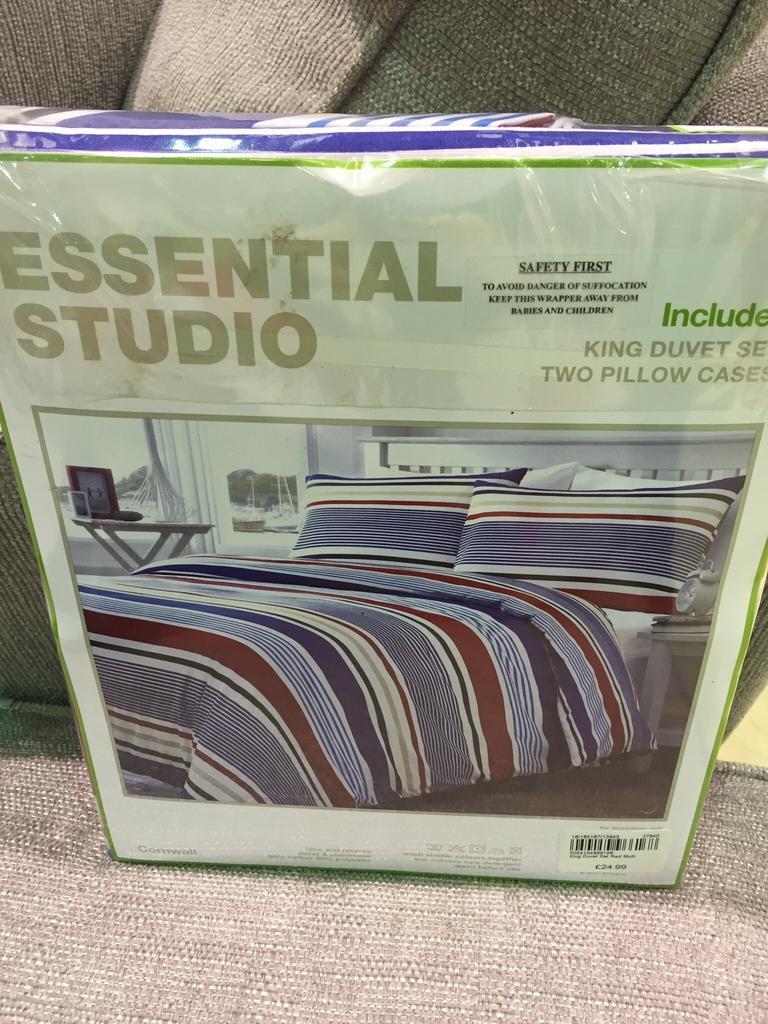Could you give a brief overview of what you see in this image? There is a box on which there is a photo of a bed. 